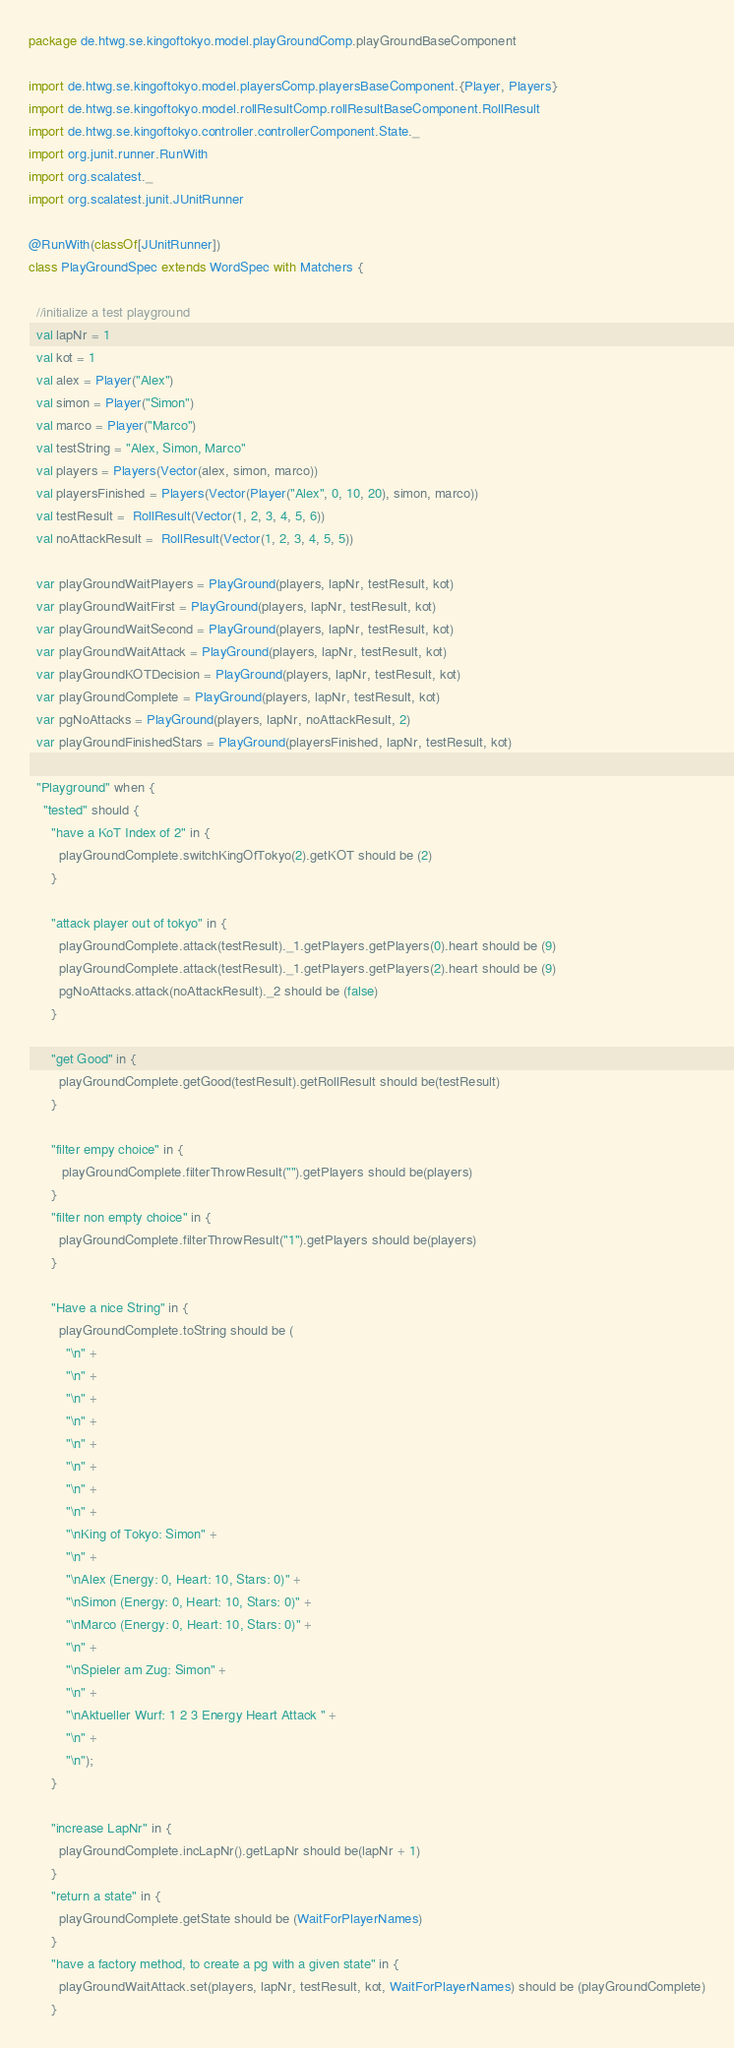<code> <loc_0><loc_0><loc_500><loc_500><_Scala_>
package de.htwg.se.kingoftokyo.model.playGroundComp.playGroundBaseComponent

import de.htwg.se.kingoftokyo.model.playersComp.playersBaseComponent.{Player, Players}
import de.htwg.se.kingoftokyo.model.rollResultComp.rollResultBaseComponent.RollResult
import de.htwg.se.kingoftokyo.controller.controllerComponent.State._
import org.junit.runner.RunWith
import org.scalatest._
import org.scalatest.junit.JUnitRunner

@RunWith(classOf[JUnitRunner])
class PlayGroundSpec extends WordSpec with Matchers {

  //initialize a test playground
  val lapNr = 1
  val kot = 1
  val alex = Player("Alex")
  val simon = Player("Simon")
  val marco = Player("Marco")
  val testString = "Alex, Simon, Marco"
  val players = Players(Vector(alex, simon, marco))
  val playersFinished = Players(Vector(Player("Alex", 0, 10, 20), simon, marco))
  val testResult =  RollResult(Vector(1, 2, 3, 4, 5, 6))
  val noAttackResult =  RollResult(Vector(1, 2, 3, 4, 5, 5))

  var playGroundWaitPlayers = PlayGround(players, lapNr, testResult, kot)
  var playGroundWaitFirst = PlayGround(players, lapNr, testResult, kot)
  var playGroundWaitSecond = PlayGround(players, lapNr, testResult, kot)
  var playGroundWaitAttack = PlayGround(players, lapNr, testResult, kot)
  var playGroundKOTDecision = PlayGround(players, lapNr, testResult, kot)
  var playGroundComplete = PlayGround(players, lapNr, testResult, kot)
  var pgNoAttacks = PlayGround(players, lapNr, noAttackResult, 2)
  var playGroundFinishedStars = PlayGround(playersFinished, lapNr, testResult, kot)

  "Playground" when {
    "tested" should {
      "have a KoT Index of 2" in {
        playGroundComplete.switchKingOfTokyo(2).getKOT should be (2)
      }

      "attack player out of tokyo" in {
        playGroundComplete.attack(testResult)._1.getPlayers.getPlayers(0).heart should be (9)
        playGroundComplete.attack(testResult)._1.getPlayers.getPlayers(2).heart should be (9)
        pgNoAttacks.attack(noAttackResult)._2 should be (false)
      }

      "get Good" in {
        playGroundComplete.getGood(testResult).getRollResult should be(testResult)
      }

      "filter empy choice" in {
         playGroundComplete.filterThrowResult("").getPlayers should be(players)
      }
      "filter non empty choice" in {
        playGroundComplete.filterThrowResult("1").getPlayers should be(players)
      }

      "Have a nice String" in {
        playGroundComplete.toString should be (
          "\n" +
          "\n" +
          "\n" +
          "\n" +
          "\n" +
          "\n" +
          "\n" +
          "\n" +
          "\nKing of Tokyo: Simon" +
          "\n" +
          "\nAlex (Energy: 0, Heart: 10, Stars: 0)" +
          "\nSimon (Energy: 0, Heart: 10, Stars: 0)" +
          "\nMarco (Energy: 0, Heart: 10, Stars: 0)" +
          "\n" +
          "\nSpieler am Zug: Simon" +
          "\n" +
          "\nAktueller Wurf: 1 2 3 Energy Heart Attack " +
          "\n" +
          "\n");
      }

      "increase LapNr" in {
        playGroundComplete.incLapNr().getLapNr should be(lapNr + 1)
      }
      "return a state" in {
        playGroundComplete.getState should be (WaitForPlayerNames)
      }
      "have a factory method, to create a pg with a given state" in {
        playGroundWaitAttack.set(players, lapNr, testResult, kot, WaitForPlayerNames) should be (playGroundComplete)
      }</code> 